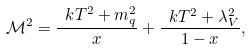<formula> <loc_0><loc_0><loc_500><loc_500>\mathcal { M } ^ { 2 } = \frac { \ k T ^ { 2 } + m _ { q } ^ { 2 } } { x } + \frac { \ k T ^ { 2 } + \lambda _ { V } ^ { 2 } } { 1 - x } ,</formula> 